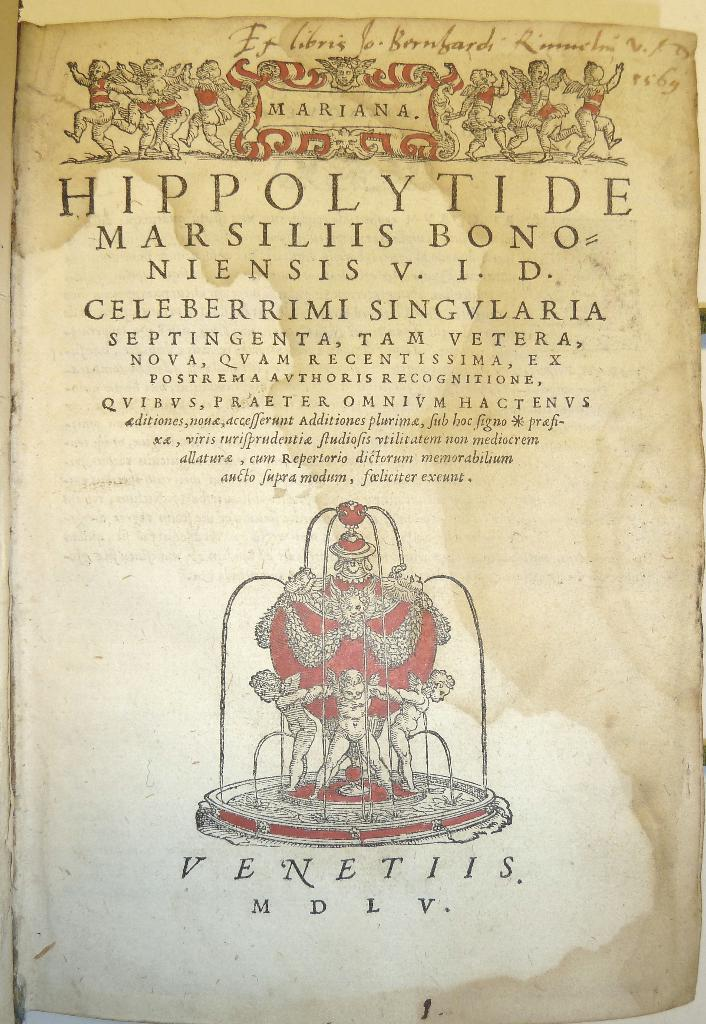What is present on the paper in the image? The paper has a painting on it. Is there any text on the paper? Yes, there is text written on the paper. What type of pancake is shown in the painting on the paper? There is no pancake present in the painting on the paper; it features a different subject. 